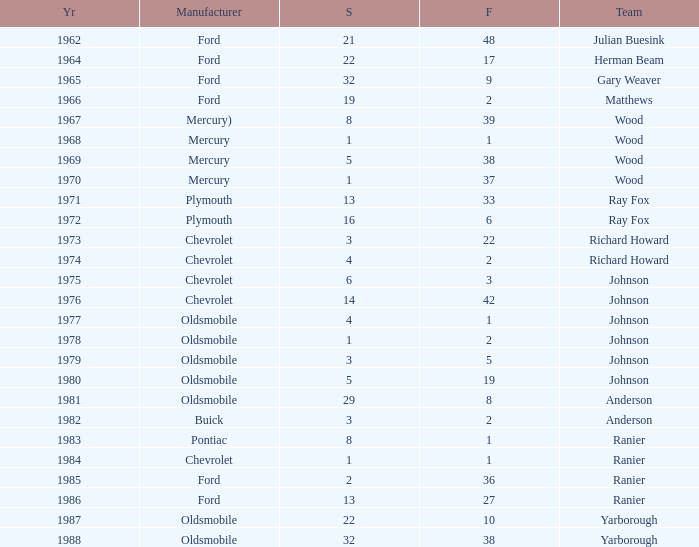Could you help me parse every detail presented in this table? {'header': ['Yr', 'Manufacturer', 'S', 'F', 'Team'], 'rows': [['1962', 'Ford', '21', '48', 'Julian Buesink'], ['1964', 'Ford', '22', '17', 'Herman Beam'], ['1965', 'Ford', '32', '9', 'Gary Weaver'], ['1966', 'Ford', '19', '2', 'Matthews'], ['1967', 'Mercury)', '8', '39', 'Wood'], ['1968', 'Mercury', '1', '1', 'Wood'], ['1969', 'Mercury', '5', '38', 'Wood'], ['1970', 'Mercury', '1', '37', 'Wood'], ['1971', 'Plymouth', '13', '33', 'Ray Fox'], ['1972', 'Plymouth', '16', '6', 'Ray Fox'], ['1973', 'Chevrolet', '3', '22', 'Richard Howard'], ['1974', 'Chevrolet', '4', '2', 'Richard Howard'], ['1975', 'Chevrolet', '6', '3', 'Johnson'], ['1976', 'Chevrolet', '14', '42', 'Johnson'], ['1977', 'Oldsmobile', '4', '1', 'Johnson'], ['1978', 'Oldsmobile', '1', '2', 'Johnson'], ['1979', 'Oldsmobile', '3', '5', 'Johnson'], ['1980', 'Oldsmobile', '5', '19', 'Johnson'], ['1981', 'Oldsmobile', '29', '8', 'Anderson'], ['1982', 'Buick', '3', '2', 'Anderson'], ['1983', 'Pontiac', '8', '1', 'Ranier'], ['1984', 'Chevrolet', '1', '1', 'Ranier'], ['1985', 'Ford', '2', '36', 'Ranier'], ['1986', 'Ford', '13', '27', 'Ranier'], ['1987', 'Oldsmobile', '22', '10', 'Yarborough'], ['1988', 'Oldsmobile', '32', '38', 'Yarborough']]} Who was the maufacturer of the vehicle during the race where Cale Yarborough started at 19 and finished earlier than 42? Ford. 